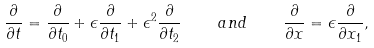Convert formula to latex. <formula><loc_0><loc_0><loc_500><loc_500>\frac { \partial } { \partial t } = \frac { \partial } { \partial t _ { 0 } } + \epsilon \frac { \partial } { \partial t _ { 1 } } + \epsilon ^ { 2 } \frac { \partial } { \partial t _ { 2 } } \quad a n d \quad \frac { \partial } { \partial x } = \epsilon \frac { \partial } { \partial x _ { 1 } } ,</formula> 